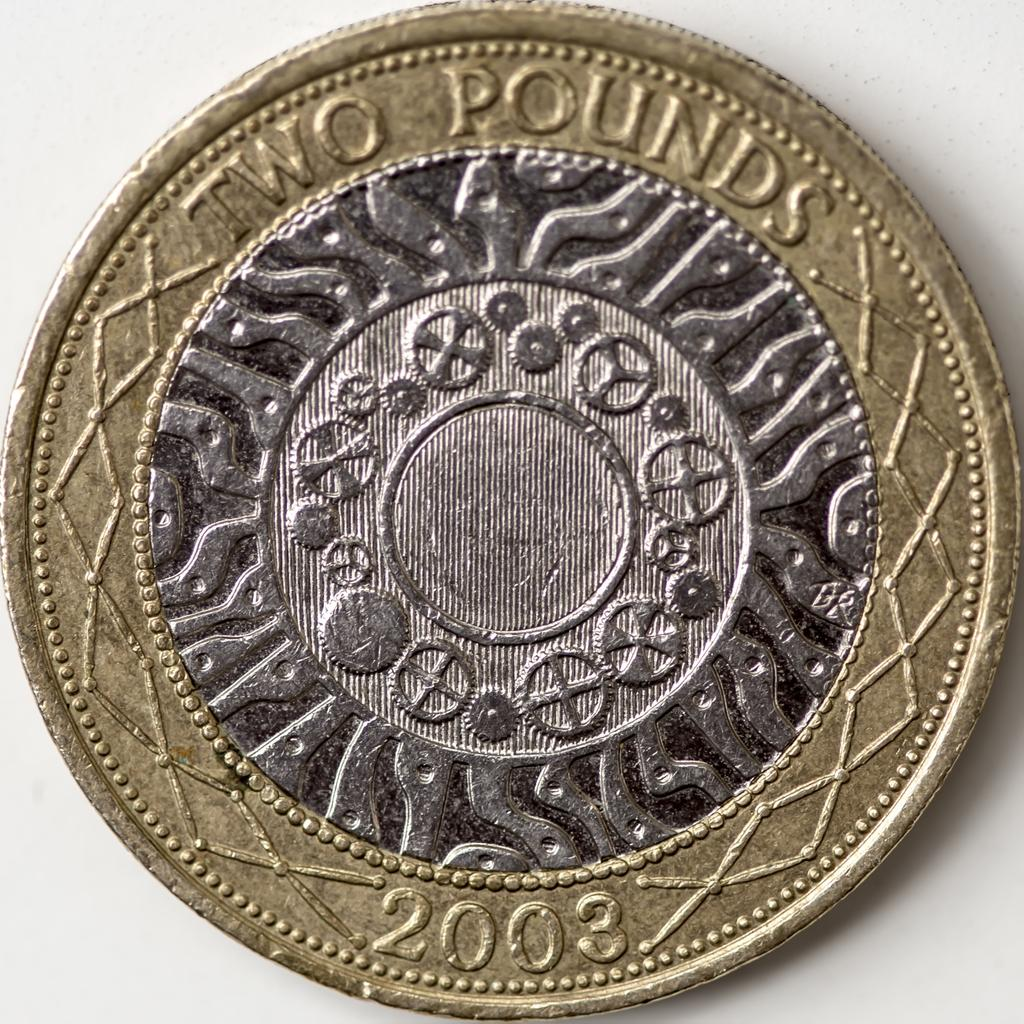<image>
Share a concise interpretation of the image provided. Two pound cent made in 2003 with a gold ring around the outside and silver inside. 